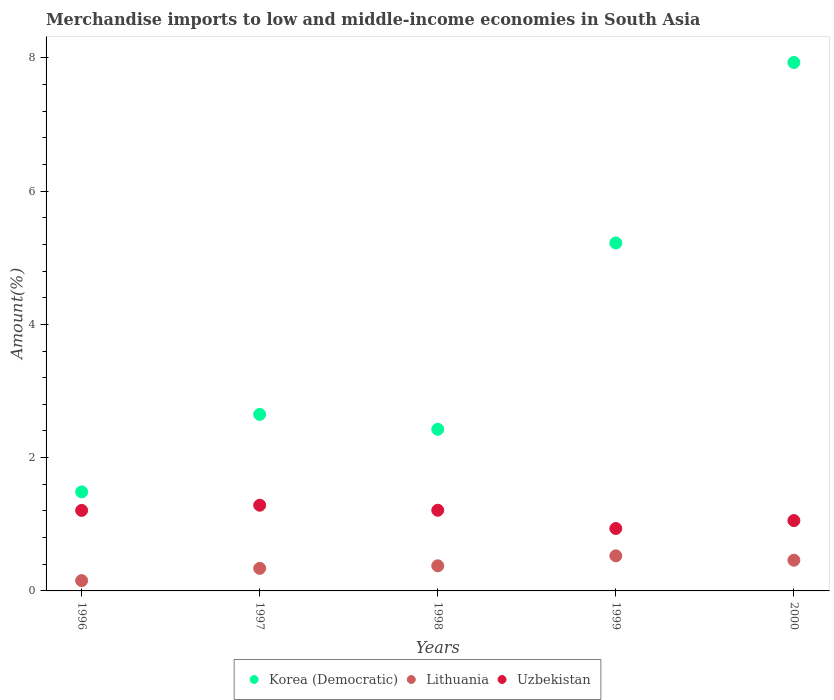How many different coloured dotlines are there?
Provide a short and direct response. 3. What is the percentage of amount earned from merchandise imports in Korea (Democratic) in 1998?
Provide a succinct answer. 2.43. Across all years, what is the maximum percentage of amount earned from merchandise imports in Korea (Democratic)?
Your response must be concise. 7.93. Across all years, what is the minimum percentage of amount earned from merchandise imports in Lithuania?
Offer a terse response. 0.15. What is the total percentage of amount earned from merchandise imports in Lithuania in the graph?
Keep it short and to the point. 1.86. What is the difference between the percentage of amount earned from merchandise imports in Korea (Democratic) in 1997 and that in 2000?
Provide a short and direct response. -5.28. What is the difference between the percentage of amount earned from merchandise imports in Lithuania in 1997 and the percentage of amount earned from merchandise imports in Korea (Democratic) in 2000?
Your response must be concise. -7.59. What is the average percentage of amount earned from merchandise imports in Uzbekistan per year?
Ensure brevity in your answer.  1.14. In the year 1997, what is the difference between the percentage of amount earned from merchandise imports in Uzbekistan and percentage of amount earned from merchandise imports in Lithuania?
Keep it short and to the point. 0.95. What is the ratio of the percentage of amount earned from merchandise imports in Lithuania in 1997 to that in 1998?
Give a very brief answer. 0.9. Is the percentage of amount earned from merchandise imports in Uzbekistan in 1996 less than that in 1999?
Keep it short and to the point. No. Is the difference between the percentage of amount earned from merchandise imports in Uzbekistan in 1998 and 1999 greater than the difference between the percentage of amount earned from merchandise imports in Lithuania in 1998 and 1999?
Your response must be concise. Yes. What is the difference between the highest and the second highest percentage of amount earned from merchandise imports in Uzbekistan?
Ensure brevity in your answer.  0.08. What is the difference between the highest and the lowest percentage of amount earned from merchandise imports in Korea (Democratic)?
Provide a short and direct response. 6.44. In how many years, is the percentage of amount earned from merchandise imports in Uzbekistan greater than the average percentage of amount earned from merchandise imports in Uzbekistan taken over all years?
Keep it short and to the point. 3. Is it the case that in every year, the sum of the percentage of amount earned from merchandise imports in Uzbekistan and percentage of amount earned from merchandise imports in Korea (Democratic)  is greater than the percentage of amount earned from merchandise imports in Lithuania?
Ensure brevity in your answer.  Yes. Is the percentage of amount earned from merchandise imports in Korea (Democratic) strictly greater than the percentage of amount earned from merchandise imports in Lithuania over the years?
Provide a succinct answer. Yes. How many dotlines are there?
Offer a terse response. 3. How many years are there in the graph?
Keep it short and to the point. 5. Are the values on the major ticks of Y-axis written in scientific E-notation?
Offer a very short reply. No. What is the title of the graph?
Provide a succinct answer. Merchandise imports to low and middle-income economies in South Asia. Does "United Kingdom" appear as one of the legend labels in the graph?
Keep it short and to the point. No. What is the label or title of the Y-axis?
Provide a succinct answer. Amount(%). What is the Amount(%) in Korea (Democratic) in 1996?
Your response must be concise. 1.49. What is the Amount(%) in Lithuania in 1996?
Your response must be concise. 0.15. What is the Amount(%) of Uzbekistan in 1996?
Provide a short and direct response. 1.21. What is the Amount(%) in Korea (Democratic) in 1997?
Your answer should be compact. 2.65. What is the Amount(%) of Lithuania in 1997?
Offer a terse response. 0.34. What is the Amount(%) in Uzbekistan in 1997?
Keep it short and to the point. 1.29. What is the Amount(%) in Korea (Democratic) in 1998?
Your answer should be very brief. 2.43. What is the Amount(%) of Lithuania in 1998?
Your answer should be very brief. 0.38. What is the Amount(%) in Uzbekistan in 1998?
Ensure brevity in your answer.  1.21. What is the Amount(%) of Korea (Democratic) in 1999?
Make the answer very short. 5.22. What is the Amount(%) of Lithuania in 1999?
Give a very brief answer. 0.53. What is the Amount(%) in Uzbekistan in 1999?
Make the answer very short. 0.94. What is the Amount(%) of Korea (Democratic) in 2000?
Keep it short and to the point. 7.93. What is the Amount(%) of Lithuania in 2000?
Provide a short and direct response. 0.46. What is the Amount(%) of Uzbekistan in 2000?
Ensure brevity in your answer.  1.06. Across all years, what is the maximum Amount(%) of Korea (Democratic)?
Make the answer very short. 7.93. Across all years, what is the maximum Amount(%) in Lithuania?
Your answer should be compact. 0.53. Across all years, what is the maximum Amount(%) in Uzbekistan?
Ensure brevity in your answer.  1.29. Across all years, what is the minimum Amount(%) in Korea (Democratic)?
Make the answer very short. 1.49. Across all years, what is the minimum Amount(%) of Lithuania?
Your answer should be very brief. 0.15. Across all years, what is the minimum Amount(%) of Uzbekistan?
Provide a short and direct response. 0.94. What is the total Amount(%) in Korea (Democratic) in the graph?
Offer a very short reply. 19.71. What is the total Amount(%) of Lithuania in the graph?
Offer a terse response. 1.86. What is the total Amount(%) in Uzbekistan in the graph?
Make the answer very short. 5.7. What is the difference between the Amount(%) of Korea (Democratic) in 1996 and that in 1997?
Provide a succinct answer. -1.16. What is the difference between the Amount(%) in Lithuania in 1996 and that in 1997?
Make the answer very short. -0.18. What is the difference between the Amount(%) of Uzbekistan in 1996 and that in 1997?
Your answer should be very brief. -0.08. What is the difference between the Amount(%) in Korea (Democratic) in 1996 and that in 1998?
Offer a terse response. -0.94. What is the difference between the Amount(%) in Lithuania in 1996 and that in 1998?
Offer a terse response. -0.22. What is the difference between the Amount(%) in Uzbekistan in 1996 and that in 1998?
Your answer should be very brief. -0. What is the difference between the Amount(%) of Korea (Democratic) in 1996 and that in 1999?
Your response must be concise. -3.73. What is the difference between the Amount(%) in Lithuania in 1996 and that in 1999?
Provide a succinct answer. -0.37. What is the difference between the Amount(%) of Uzbekistan in 1996 and that in 1999?
Give a very brief answer. 0.27. What is the difference between the Amount(%) in Korea (Democratic) in 1996 and that in 2000?
Your answer should be very brief. -6.44. What is the difference between the Amount(%) in Lithuania in 1996 and that in 2000?
Your answer should be compact. -0.31. What is the difference between the Amount(%) of Uzbekistan in 1996 and that in 2000?
Ensure brevity in your answer.  0.15. What is the difference between the Amount(%) of Korea (Democratic) in 1997 and that in 1998?
Offer a terse response. 0.22. What is the difference between the Amount(%) of Lithuania in 1997 and that in 1998?
Your response must be concise. -0.04. What is the difference between the Amount(%) in Uzbekistan in 1997 and that in 1998?
Make the answer very short. 0.08. What is the difference between the Amount(%) in Korea (Democratic) in 1997 and that in 1999?
Offer a terse response. -2.57. What is the difference between the Amount(%) of Lithuania in 1997 and that in 1999?
Your response must be concise. -0.19. What is the difference between the Amount(%) in Uzbekistan in 1997 and that in 1999?
Your response must be concise. 0.35. What is the difference between the Amount(%) of Korea (Democratic) in 1997 and that in 2000?
Your answer should be very brief. -5.28. What is the difference between the Amount(%) of Lithuania in 1997 and that in 2000?
Provide a succinct answer. -0.12. What is the difference between the Amount(%) of Uzbekistan in 1997 and that in 2000?
Give a very brief answer. 0.23. What is the difference between the Amount(%) of Korea (Democratic) in 1998 and that in 1999?
Make the answer very short. -2.8. What is the difference between the Amount(%) in Lithuania in 1998 and that in 1999?
Offer a very short reply. -0.15. What is the difference between the Amount(%) of Uzbekistan in 1998 and that in 1999?
Your response must be concise. 0.27. What is the difference between the Amount(%) of Korea (Democratic) in 1998 and that in 2000?
Your answer should be very brief. -5.5. What is the difference between the Amount(%) of Lithuania in 1998 and that in 2000?
Your answer should be very brief. -0.08. What is the difference between the Amount(%) of Uzbekistan in 1998 and that in 2000?
Provide a succinct answer. 0.15. What is the difference between the Amount(%) of Korea (Democratic) in 1999 and that in 2000?
Keep it short and to the point. -2.71. What is the difference between the Amount(%) in Lithuania in 1999 and that in 2000?
Offer a very short reply. 0.07. What is the difference between the Amount(%) of Uzbekistan in 1999 and that in 2000?
Ensure brevity in your answer.  -0.12. What is the difference between the Amount(%) of Korea (Democratic) in 1996 and the Amount(%) of Lithuania in 1997?
Your response must be concise. 1.15. What is the difference between the Amount(%) in Korea (Democratic) in 1996 and the Amount(%) in Uzbekistan in 1997?
Your response must be concise. 0.2. What is the difference between the Amount(%) of Lithuania in 1996 and the Amount(%) of Uzbekistan in 1997?
Provide a succinct answer. -1.13. What is the difference between the Amount(%) of Korea (Democratic) in 1996 and the Amount(%) of Lithuania in 1998?
Provide a short and direct response. 1.11. What is the difference between the Amount(%) of Korea (Democratic) in 1996 and the Amount(%) of Uzbekistan in 1998?
Offer a very short reply. 0.28. What is the difference between the Amount(%) of Lithuania in 1996 and the Amount(%) of Uzbekistan in 1998?
Your answer should be very brief. -1.06. What is the difference between the Amount(%) in Korea (Democratic) in 1996 and the Amount(%) in Lithuania in 1999?
Keep it short and to the point. 0.96. What is the difference between the Amount(%) of Korea (Democratic) in 1996 and the Amount(%) of Uzbekistan in 1999?
Offer a very short reply. 0.55. What is the difference between the Amount(%) of Lithuania in 1996 and the Amount(%) of Uzbekistan in 1999?
Offer a very short reply. -0.78. What is the difference between the Amount(%) in Korea (Democratic) in 1996 and the Amount(%) in Lithuania in 2000?
Offer a terse response. 1.03. What is the difference between the Amount(%) in Korea (Democratic) in 1996 and the Amount(%) in Uzbekistan in 2000?
Provide a succinct answer. 0.43. What is the difference between the Amount(%) in Lithuania in 1996 and the Amount(%) in Uzbekistan in 2000?
Ensure brevity in your answer.  -0.9. What is the difference between the Amount(%) of Korea (Democratic) in 1997 and the Amount(%) of Lithuania in 1998?
Keep it short and to the point. 2.27. What is the difference between the Amount(%) in Korea (Democratic) in 1997 and the Amount(%) in Uzbekistan in 1998?
Offer a terse response. 1.44. What is the difference between the Amount(%) of Lithuania in 1997 and the Amount(%) of Uzbekistan in 1998?
Your answer should be very brief. -0.87. What is the difference between the Amount(%) of Korea (Democratic) in 1997 and the Amount(%) of Lithuania in 1999?
Offer a very short reply. 2.12. What is the difference between the Amount(%) in Korea (Democratic) in 1997 and the Amount(%) in Uzbekistan in 1999?
Your answer should be compact. 1.71. What is the difference between the Amount(%) of Lithuania in 1997 and the Amount(%) of Uzbekistan in 1999?
Make the answer very short. -0.6. What is the difference between the Amount(%) of Korea (Democratic) in 1997 and the Amount(%) of Lithuania in 2000?
Provide a succinct answer. 2.19. What is the difference between the Amount(%) in Korea (Democratic) in 1997 and the Amount(%) in Uzbekistan in 2000?
Your answer should be compact. 1.59. What is the difference between the Amount(%) of Lithuania in 1997 and the Amount(%) of Uzbekistan in 2000?
Your answer should be very brief. -0.72. What is the difference between the Amount(%) of Korea (Democratic) in 1998 and the Amount(%) of Lithuania in 1999?
Make the answer very short. 1.9. What is the difference between the Amount(%) in Korea (Democratic) in 1998 and the Amount(%) in Uzbekistan in 1999?
Ensure brevity in your answer.  1.49. What is the difference between the Amount(%) in Lithuania in 1998 and the Amount(%) in Uzbekistan in 1999?
Make the answer very short. -0.56. What is the difference between the Amount(%) of Korea (Democratic) in 1998 and the Amount(%) of Lithuania in 2000?
Ensure brevity in your answer.  1.96. What is the difference between the Amount(%) of Korea (Democratic) in 1998 and the Amount(%) of Uzbekistan in 2000?
Your answer should be compact. 1.37. What is the difference between the Amount(%) in Lithuania in 1998 and the Amount(%) in Uzbekistan in 2000?
Keep it short and to the point. -0.68. What is the difference between the Amount(%) of Korea (Democratic) in 1999 and the Amount(%) of Lithuania in 2000?
Your answer should be very brief. 4.76. What is the difference between the Amount(%) of Korea (Democratic) in 1999 and the Amount(%) of Uzbekistan in 2000?
Provide a succinct answer. 4.17. What is the difference between the Amount(%) of Lithuania in 1999 and the Amount(%) of Uzbekistan in 2000?
Keep it short and to the point. -0.53. What is the average Amount(%) in Korea (Democratic) per year?
Provide a short and direct response. 3.94. What is the average Amount(%) in Lithuania per year?
Provide a short and direct response. 0.37. What is the average Amount(%) in Uzbekistan per year?
Provide a succinct answer. 1.14. In the year 1996, what is the difference between the Amount(%) of Korea (Democratic) and Amount(%) of Lithuania?
Make the answer very short. 1.33. In the year 1996, what is the difference between the Amount(%) of Korea (Democratic) and Amount(%) of Uzbekistan?
Provide a succinct answer. 0.28. In the year 1996, what is the difference between the Amount(%) of Lithuania and Amount(%) of Uzbekistan?
Give a very brief answer. -1.05. In the year 1997, what is the difference between the Amount(%) of Korea (Democratic) and Amount(%) of Lithuania?
Ensure brevity in your answer.  2.31. In the year 1997, what is the difference between the Amount(%) of Korea (Democratic) and Amount(%) of Uzbekistan?
Provide a succinct answer. 1.36. In the year 1997, what is the difference between the Amount(%) of Lithuania and Amount(%) of Uzbekistan?
Make the answer very short. -0.95. In the year 1998, what is the difference between the Amount(%) in Korea (Democratic) and Amount(%) in Lithuania?
Your response must be concise. 2.05. In the year 1998, what is the difference between the Amount(%) in Korea (Democratic) and Amount(%) in Uzbekistan?
Your response must be concise. 1.21. In the year 1998, what is the difference between the Amount(%) of Lithuania and Amount(%) of Uzbekistan?
Your response must be concise. -0.83. In the year 1999, what is the difference between the Amount(%) in Korea (Democratic) and Amount(%) in Lithuania?
Keep it short and to the point. 4.69. In the year 1999, what is the difference between the Amount(%) of Korea (Democratic) and Amount(%) of Uzbekistan?
Keep it short and to the point. 4.28. In the year 1999, what is the difference between the Amount(%) in Lithuania and Amount(%) in Uzbekistan?
Your answer should be very brief. -0.41. In the year 2000, what is the difference between the Amount(%) in Korea (Democratic) and Amount(%) in Lithuania?
Provide a short and direct response. 7.47. In the year 2000, what is the difference between the Amount(%) in Korea (Democratic) and Amount(%) in Uzbekistan?
Provide a succinct answer. 6.87. In the year 2000, what is the difference between the Amount(%) in Lithuania and Amount(%) in Uzbekistan?
Keep it short and to the point. -0.59. What is the ratio of the Amount(%) in Korea (Democratic) in 1996 to that in 1997?
Your answer should be very brief. 0.56. What is the ratio of the Amount(%) of Lithuania in 1996 to that in 1997?
Provide a short and direct response. 0.46. What is the ratio of the Amount(%) of Uzbekistan in 1996 to that in 1997?
Offer a terse response. 0.94. What is the ratio of the Amount(%) in Korea (Democratic) in 1996 to that in 1998?
Provide a succinct answer. 0.61. What is the ratio of the Amount(%) of Lithuania in 1996 to that in 1998?
Make the answer very short. 0.41. What is the ratio of the Amount(%) of Uzbekistan in 1996 to that in 1998?
Your answer should be compact. 1. What is the ratio of the Amount(%) in Korea (Democratic) in 1996 to that in 1999?
Ensure brevity in your answer.  0.28. What is the ratio of the Amount(%) in Lithuania in 1996 to that in 1999?
Your answer should be compact. 0.29. What is the ratio of the Amount(%) of Uzbekistan in 1996 to that in 1999?
Provide a short and direct response. 1.29. What is the ratio of the Amount(%) in Korea (Democratic) in 1996 to that in 2000?
Keep it short and to the point. 0.19. What is the ratio of the Amount(%) in Lithuania in 1996 to that in 2000?
Offer a very short reply. 0.34. What is the ratio of the Amount(%) of Uzbekistan in 1996 to that in 2000?
Provide a succinct answer. 1.14. What is the ratio of the Amount(%) in Korea (Democratic) in 1997 to that in 1998?
Make the answer very short. 1.09. What is the ratio of the Amount(%) of Lithuania in 1997 to that in 1998?
Ensure brevity in your answer.  0.9. What is the ratio of the Amount(%) of Uzbekistan in 1997 to that in 1998?
Offer a very short reply. 1.06. What is the ratio of the Amount(%) of Korea (Democratic) in 1997 to that in 1999?
Ensure brevity in your answer.  0.51. What is the ratio of the Amount(%) of Lithuania in 1997 to that in 1999?
Offer a very short reply. 0.64. What is the ratio of the Amount(%) in Uzbekistan in 1997 to that in 1999?
Offer a terse response. 1.37. What is the ratio of the Amount(%) of Korea (Democratic) in 1997 to that in 2000?
Ensure brevity in your answer.  0.33. What is the ratio of the Amount(%) of Lithuania in 1997 to that in 2000?
Offer a very short reply. 0.74. What is the ratio of the Amount(%) of Uzbekistan in 1997 to that in 2000?
Offer a terse response. 1.22. What is the ratio of the Amount(%) in Korea (Democratic) in 1998 to that in 1999?
Provide a succinct answer. 0.46. What is the ratio of the Amount(%) of Lithuania in 1998 to that in 1999?
Offer a terse response. 0.72. What is the ratio of the Amount(%) of Uzbekistan in 1998 to that in 1999?
Your answer should be very brief. 1.29. What is the ratio of the Amount(%) in Korea (Democratic) in 1998 to that in 2000?
Keep it short and to the point. 0.31. What is the ratio of the Amount(%) in Lithuania in 1998 to that in 2000?
Your answer should be compact. 0.82. What is the ratio of the Amount(%) in Uzbekistan in 1998 to that in 2000?
Make the answer very short. 1.15. What is the ratio of the Amount(%) of Korea (Democratic) in 1999 to that in 2000?
Your response must be concise. 0.66. What is the ratio of the Amount(%) in Lithuania in 1999 to that in 2000?
Your response must be concise. 1.14. What is the ratio of the Amount(%) in Uzbekistan in 1999 to that in 2000?
Provide a succinct answer. 0.89. What is the difference between the highest and the second highest Amount(%) of Korea (Democratic)?
Provide a succinct answer. 2.71. What is the difference between the highest and the second highest Amount(%) of Lithuania?
Your answer should be very brief. 0.07. What is the difference between the highest and the second highest Amount(%) of Uzbekistan?
Offer a terse response. 0.08. What is the difference between the highest and the lowest Amount(%) of Korea (Democratic)?
Make the answer very short. 6.44. What is the difference between the highest and the lowest Amount(%) in Lithuania?
Provide a succinct answer. 0.37. What is the difference between the highest and the lowest Amount(%) in Uzbekistan?
Your answer should be compact. 0.35. 